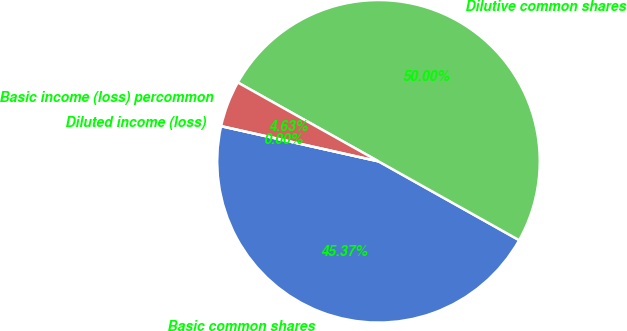Convert chart to OTSL. <chart><loc_0><loc_0><loc_500><loc_500><pie_chart><fcel>Basic common shares<fcel>Dilutive common shares<fcel>Basic income (loss) percommon<fcel>Diluted income (loss)<nl><fcel>45.37%<fcel>50.0%<fcel>4.63%<fcel>0.0%<nl></chart> 